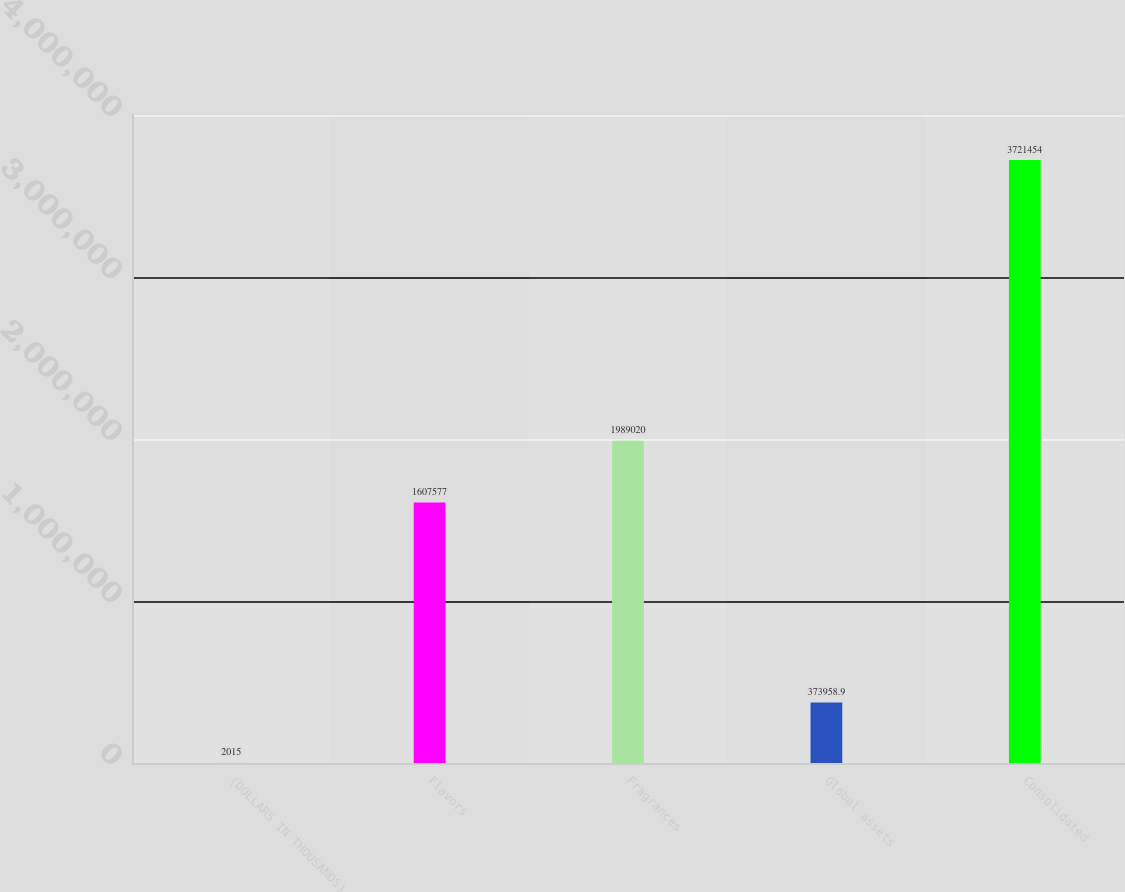Convert chart to OTSL. <chart><loc_0><loc_0><loc_500><loc_500><bar_chart><fcel>(DOLLARS IN THOUSANDS)<fcel>Flavors<fcel>Fragrances<fcel>Global assets<fcel>Consolidated<nl><fcel>2015<fcel>1.60758e+06<fcel>1.98902e+06<fcel>373959<fcel>3.72145e+06<nl></chart> 